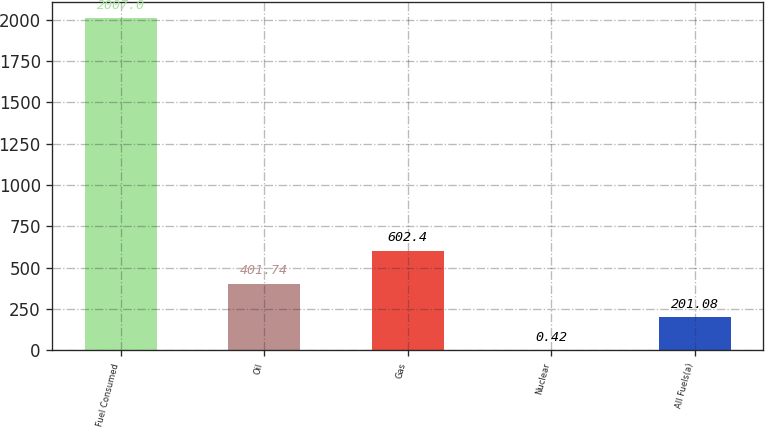Convert chart to OTSL. <chart><loc_0><loc_0><loc_500><loc_500><bar_chart><fcel>Fuel Consumed<fcel>Oil<fcel>Gas<fcel>Nuclear<fcel>All Fuels(a)<nl><fcel>2007<fcel>401.74<fcel>602.4<fcel>0.42<fcel>201.08<nl></chart> 